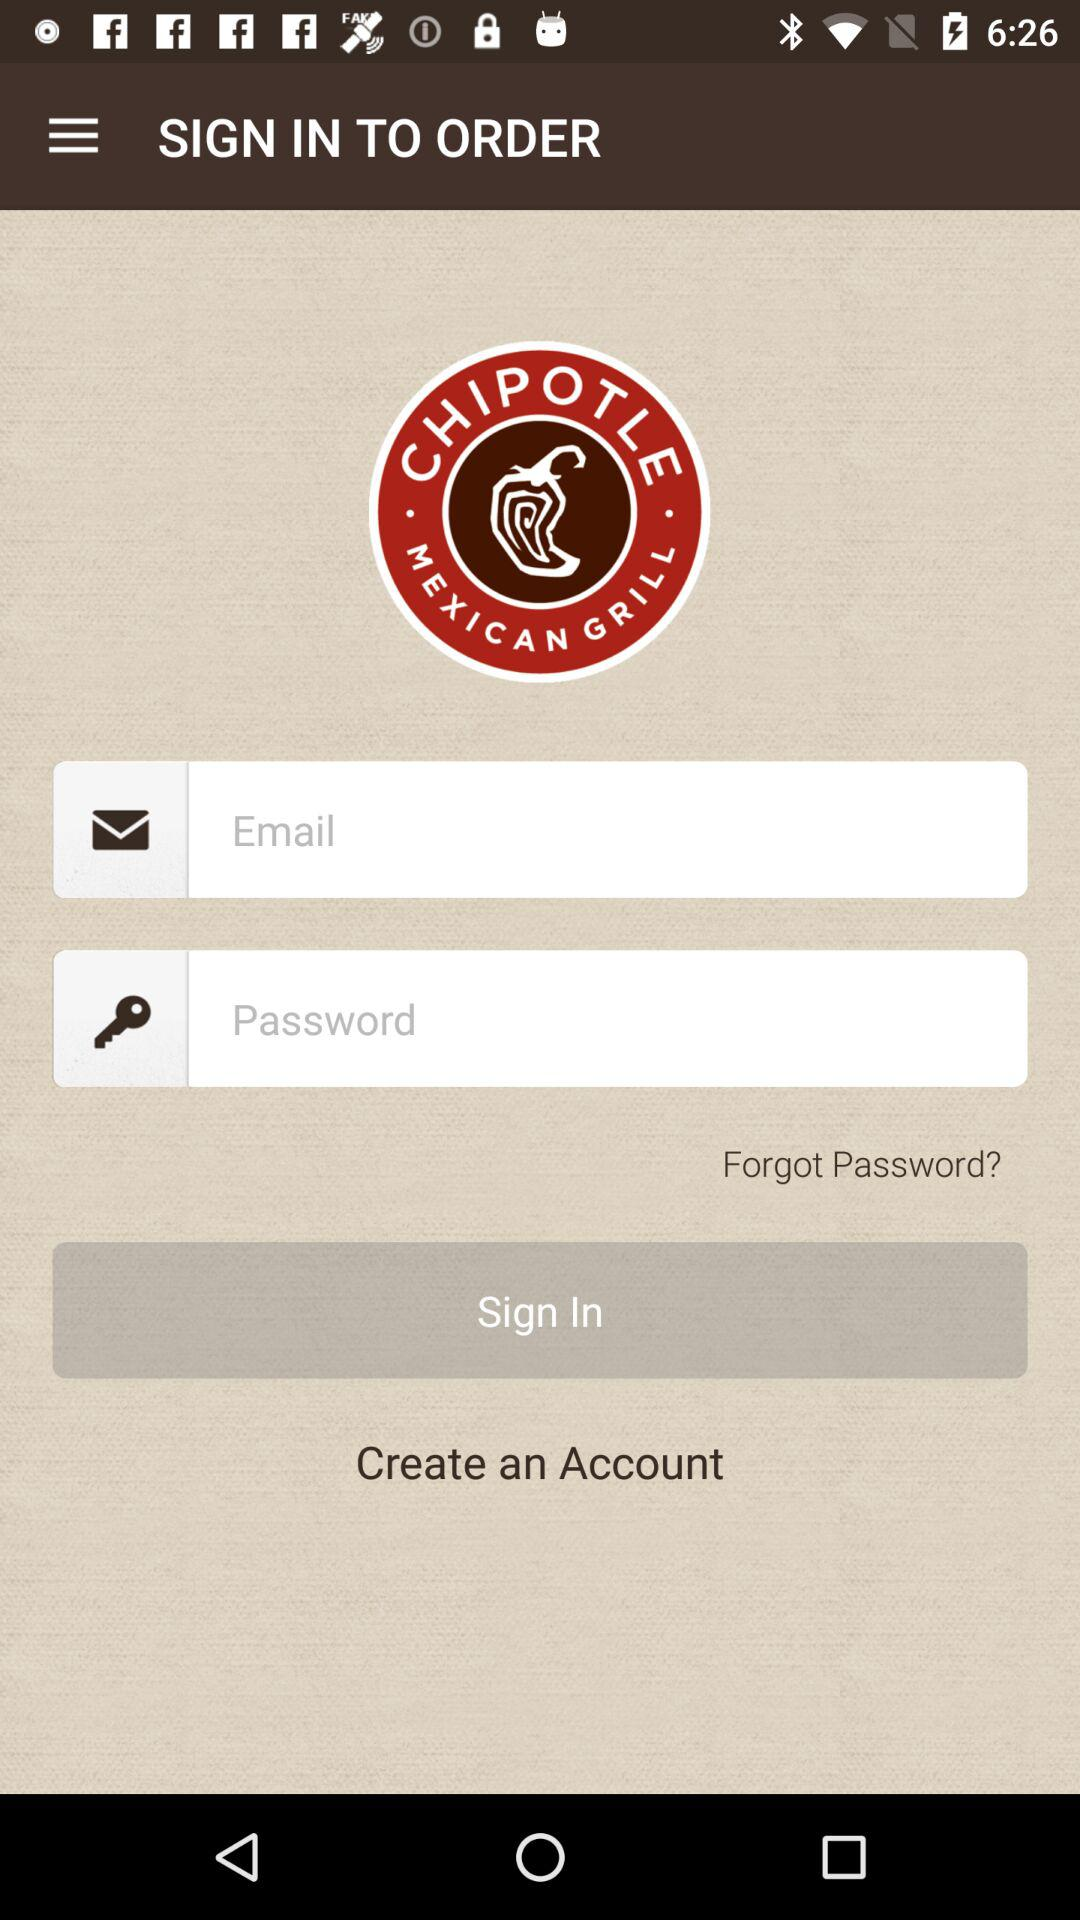How many input fields are on this page?
Answer the question using a single word or phrase. 2 